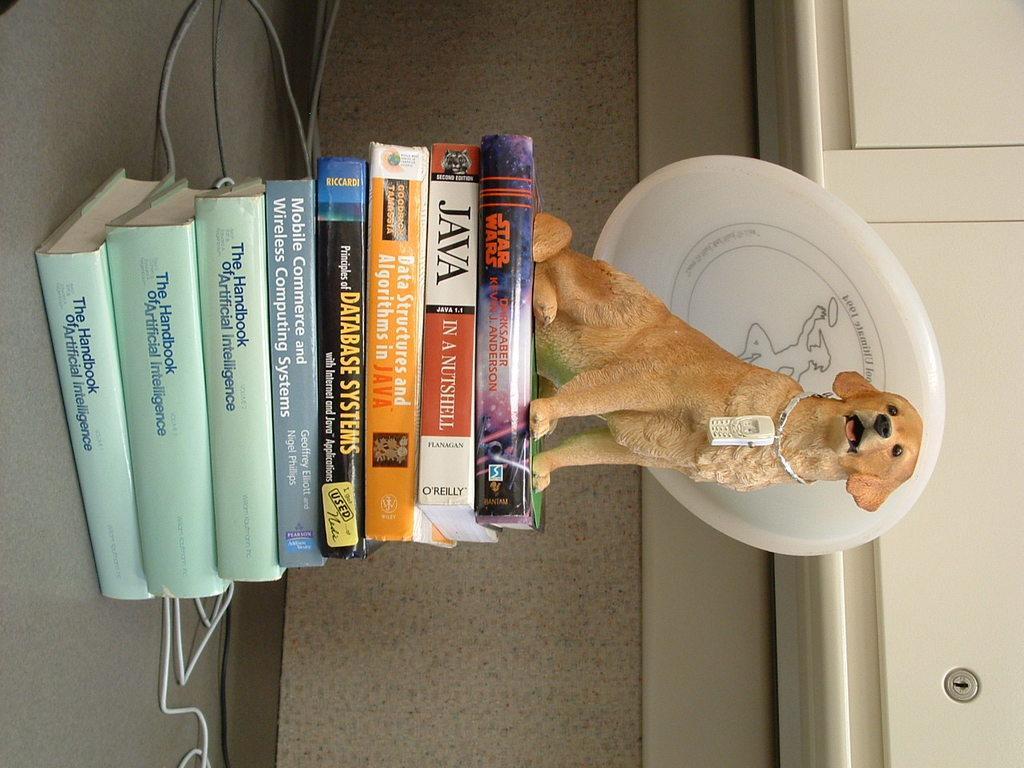How would you summarize this image in a sentence or two? In this image I can see few books and on the top of it I can see a cream colour dog. I can also see a white colour thing around the dog's neck. In the background I can see few wires and a white colour thing. 